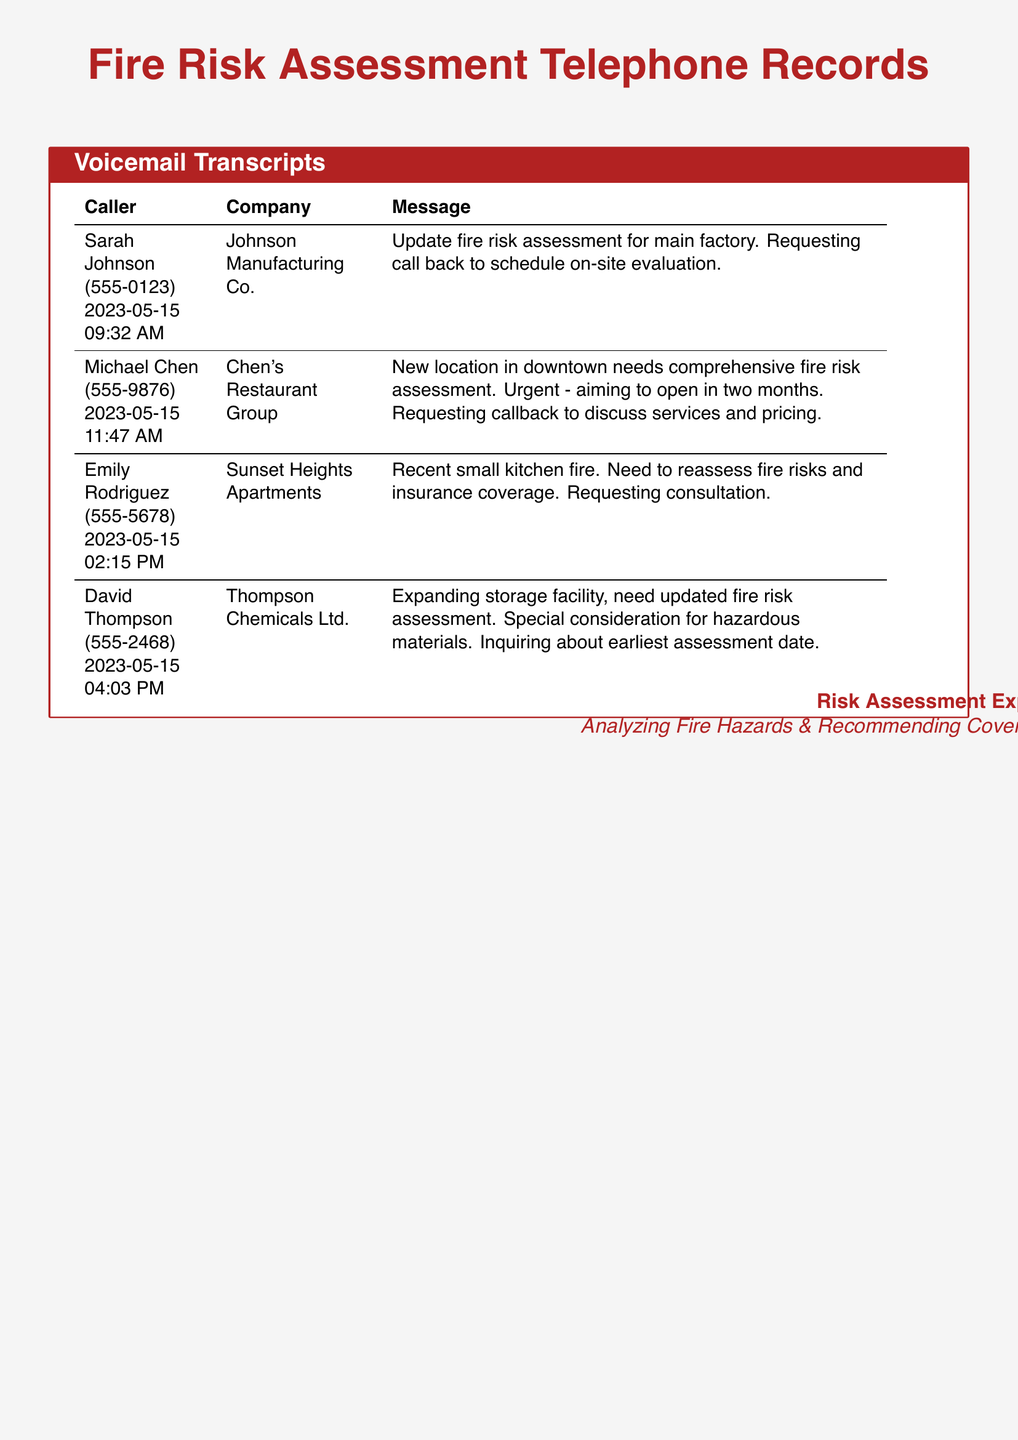What is the name of the first caller? The first caller listed in the document is Sarah Johnson, who contacted on 2023-05-15.
Answer: Sarah Johnson What is the date and time of Michael Chen's call? Michael Chen's call is dated 2023-05-15 and took place at 11:47 AM.
Answer: 2023-05-15 11:47 AM What is the focus of Emily Rodriguez's request? Emily Rodriguez's message indicates the need to reassess fire risks due to a recent small kitchen fire.
Answer: Reassess fire risks How many callers are requesting a callback? Three callers specifically request a callback to discuss their needs further.
Answer: Three What type of assessment does David Thompson require? David Thompson is asking for an updated fire risk assessment, especially concerning hazardous materials.
Answer: Updated fire risk assessment What is the urgency expressed by Chen's Restaurant Group? Michael Chen indicates that the assessment is urgent due to plans to open the new location in two months.
Answer: Urgent What is the company associated with the last caller? The last caller, David Thompson, is associated with Thompson Chemicals Ltd.
Answer: Thompson Chemicals Ltd What specific consideration is mentioned in David Thompson's message? David Thompson's message mentions special consideration for hazardous materials in the assessment.
Answer: Hazardous materials 